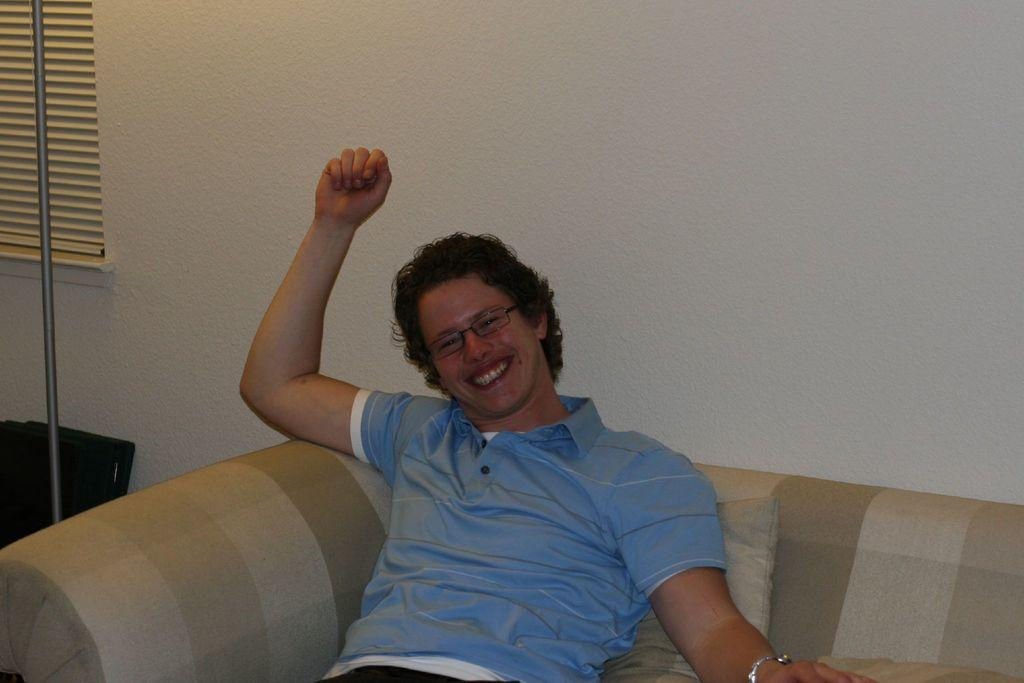What is the main subject of the image? There is a person in the image. Can you describe the person's appearance? The person is wearing glasses. What is the person doing in the image? The person is sitting on a sofa and smiling. What other objects can be seen in the image? There is a cushion, a rod, a window, and a plain wall in the image. How many steps are visible in the image? There are no steps visible in the image. What is the person's temper like in the image? The person's temper cannot be determined from the image, as it only shows them sitting on a sofa and smiling. 